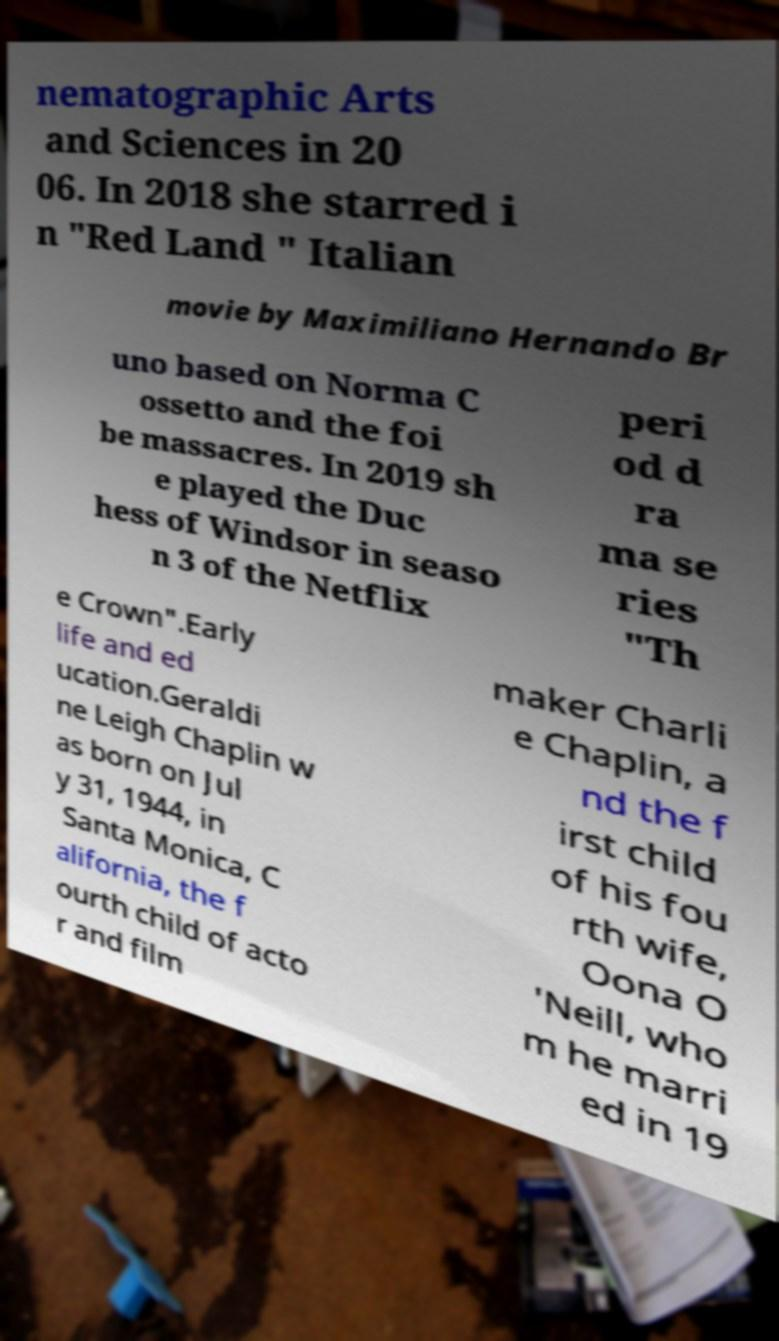Can you accurately transcribe the text from the provided image for me? nematographic Arts and Sciences in 20 06. In 2018 she starred i n "Red Land " Italian movie by Maximiliano Hernando Br uno based on Norma C ossetto and the foi be massacres. In 2019 sh e played the Duc hess of Windsor in seaso n 3 of the Netflix peri od d ra ma se ries "Th e Crown".Early life and ed ucation.Geraldi ne Leigh Chaplin w as born on Jul y 31, 1944, in Santa Monica, C alifornia, the f ourth child of acto r and film maker Charli e Chaplin, a nd the f irst child of his fou rth wife, Oona O 'Neill, who m he marri ed in 19 